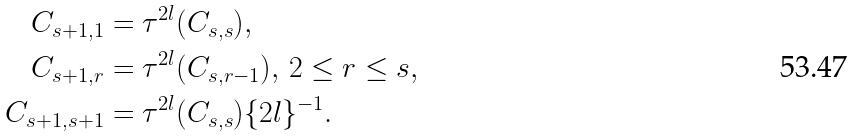Convert formula to latex. <formula><loc_0><loc_0><loc_500><loc_500>C _ { s + 1 , 1 } & = \tau ^ { 2 l } ( C _ { s , s } ) , \\ C _ { s + 1 , r } & = \tau ^ { 2 l } ( C _ { s , r - 1 } ) , \, 2 \leq r \leq s , \\ C _ { s + 1 , s + 1 } & = \tau ^ { 2 l } ( C _ { s , s } ) \{ 2 l \} ^ { - 1 } .</formula> 